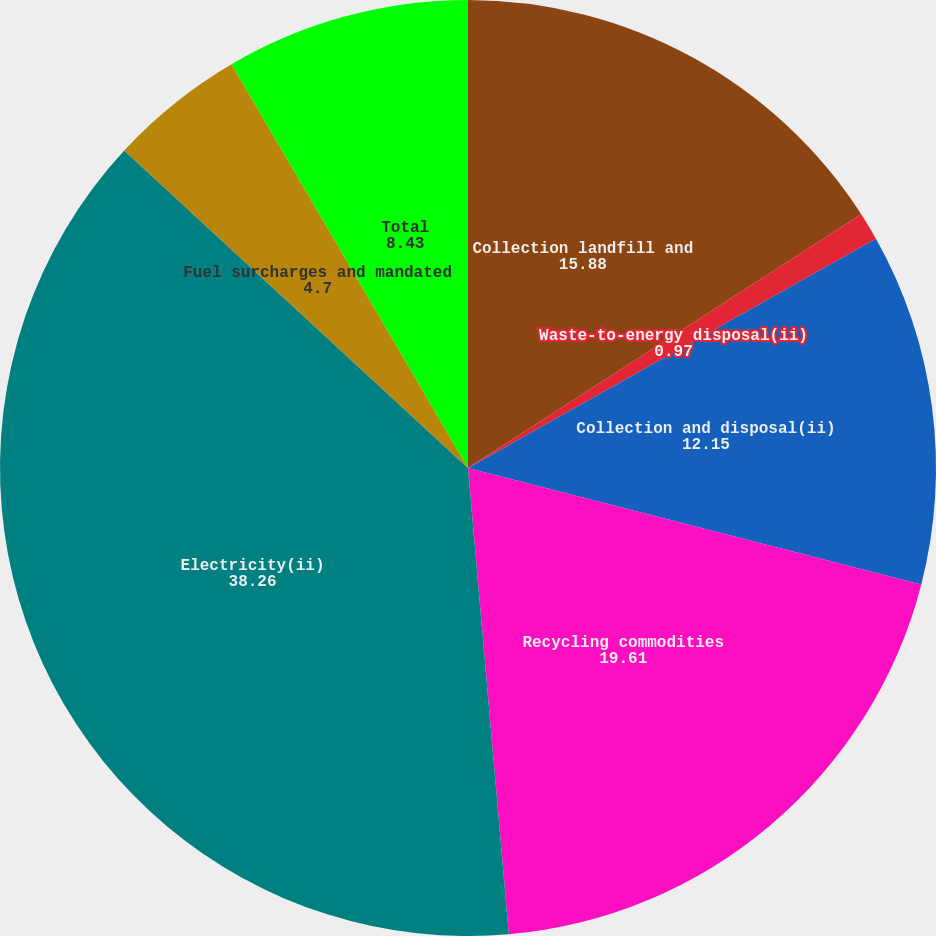Convert chart to OTSL. <chart><loc_0><loc_0><loc_500><loc_500><pie_chart><fcel>Collection landfill and<fcel>Waste-to-energy disposal(ii)<fcel>Collection and disposal(ii)<fcel>Recycling commodities<fcel>Electricity(ii)<fcel>Fuel surcharges and mandated<fcel>Total<nl><fcel>15.88%<fcel>0.97%<fcel>12.15%<fcel>19.61%<fcel>38.26%<fcel>4.7%<fcel>8.43%<nl></chart> 